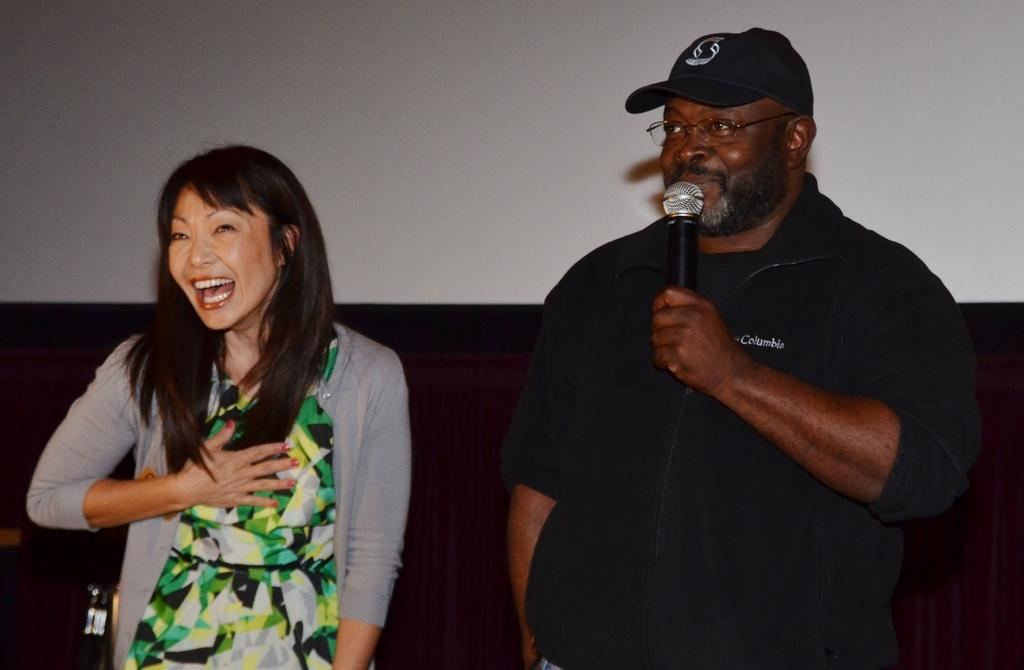What is the man doing in the image? The man is standing on the right side of the image and speaking into a microphone. What is the girl's reaction in the image? The girl is standing on the left side of the image and laughing. What month is depicted in the image? The image does not depict a specific month; it only shows the man and the girl in their respective actions and reactions. Can you describe the detail of the robin's feathers in the image? There is no robin present in the image, so it is not possible to describe the detail of its feathers. 